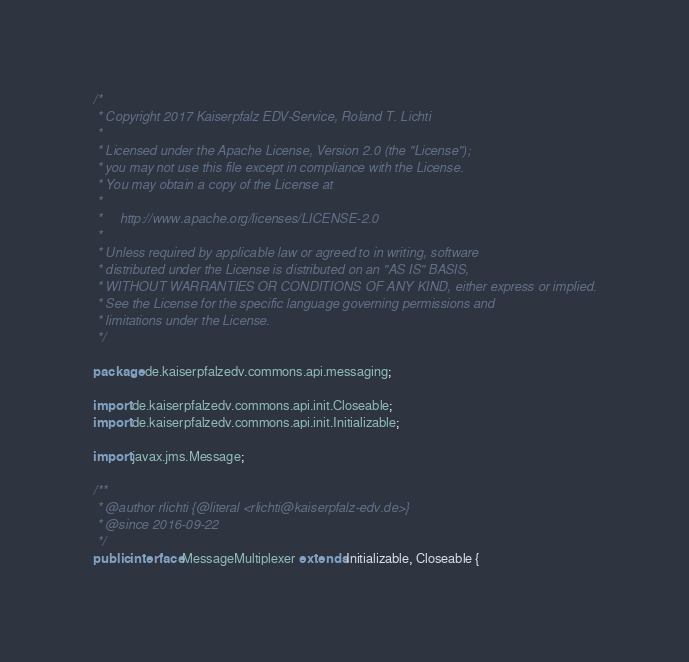<code> <loc_0><loc_0><loc_500><loc_500><_Java_>/*
 * Copyright 2017 Kaiserpfalz EDV-Service, Roland T. Lichti
 *
 * Licensed under the Apache License, Version 2.0 (the "License");
 * you may not use this file except in compliance with the License.
 * You may obtain a copy of the License at
 *
 *     http://www.apache.org/licenses/LICENSE-2.0
 *
 * Unless required by applicable law or agreed to in writing, software
 * distributed under the License is distributed on an "AS IS" BASIS,
 * WITHOUT WARRANTIES OR CONDITIONS OF ANY KIND, either express or implied.
 * See the License for the specific language governing permissions and
 * limitations under the License.
 */

package de.kaiserpfalzedv.commons.api.messaging;

import de.kaiserpfalzedv.commons.api.init.Closeable;
import de.kaiserpfalzedv.commons.api.init.Initializable;

import javax.jms.Message;

/**
 * @author rlichti {@literal <rlichti@kaiserpfalz-edv.de>}
 * @since 2016-09-22
 */
public interface MessageMultiplexer extends Initializable, Closeable {</code> 